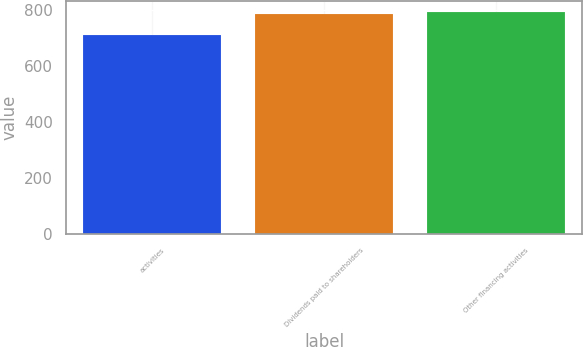Convert chart to OTSL. <chart><loc_0><loc_0><loc_500><loc_500><bar_chart><fcel>activities<fcel>Dividends paid to shareholders<fcel>Other financing activities<nl><fcel>711.6<fcel>786<fcel>793.44<nl></chart> 